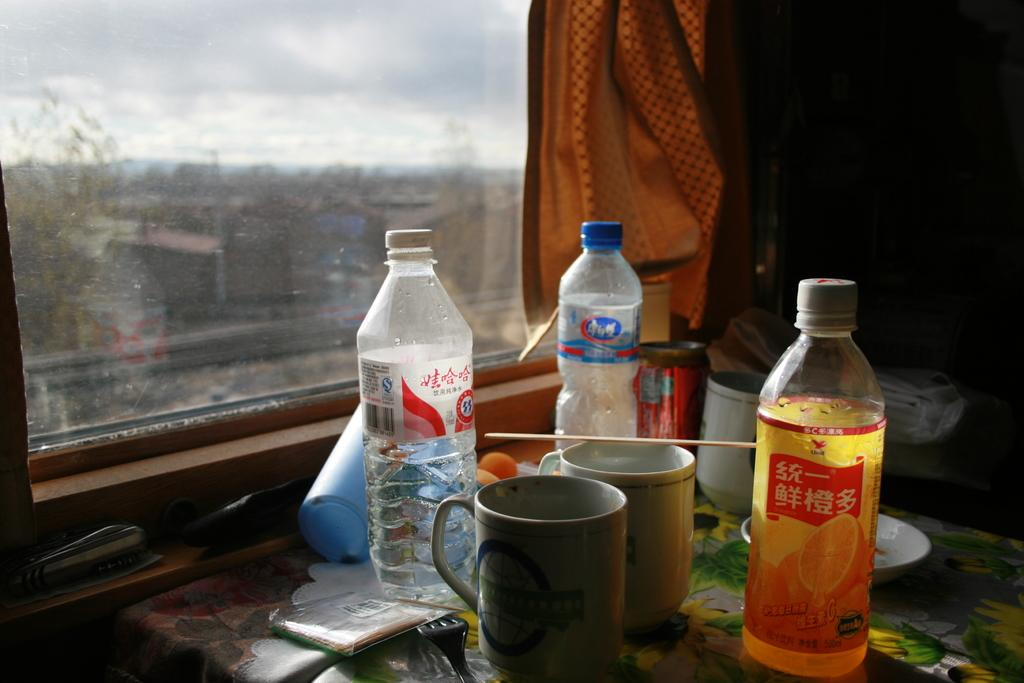What type of objects are on the table in the image? There are cups, a tin, bottles, and a fork on the table in the image. What can be seen in the background of the image? There is a window in the background of the image. Is there any window treatment present in the image? Yes, there is a curtain associated with the window. What type of whip can be seen in the image? There is no whip present in the image. What type of current is flowing through the objects in the image? There is no electrical current or any other type of current visible in the image. 